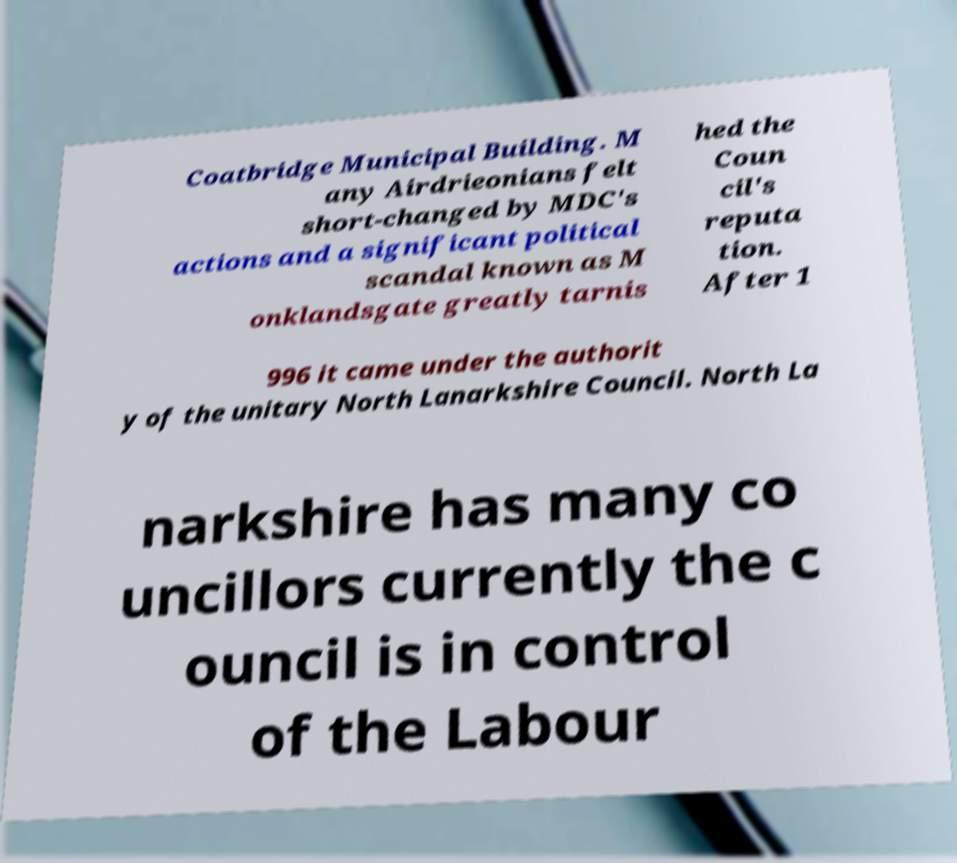I need the written content from this picture converted into text. Can you do that? Coatbridge Municipal Building. M any Airdrieonians felt short-changed by MDC's actions and a significant political scandal known as M onklandsgate greatly tarnis hed the Coun cil's reputa tion. After 1 996 it came under the authorit y of the unitary North Lanarkshire Council. North La narkshire has many co uncillors currently the c ouncil is in control of the Labour 